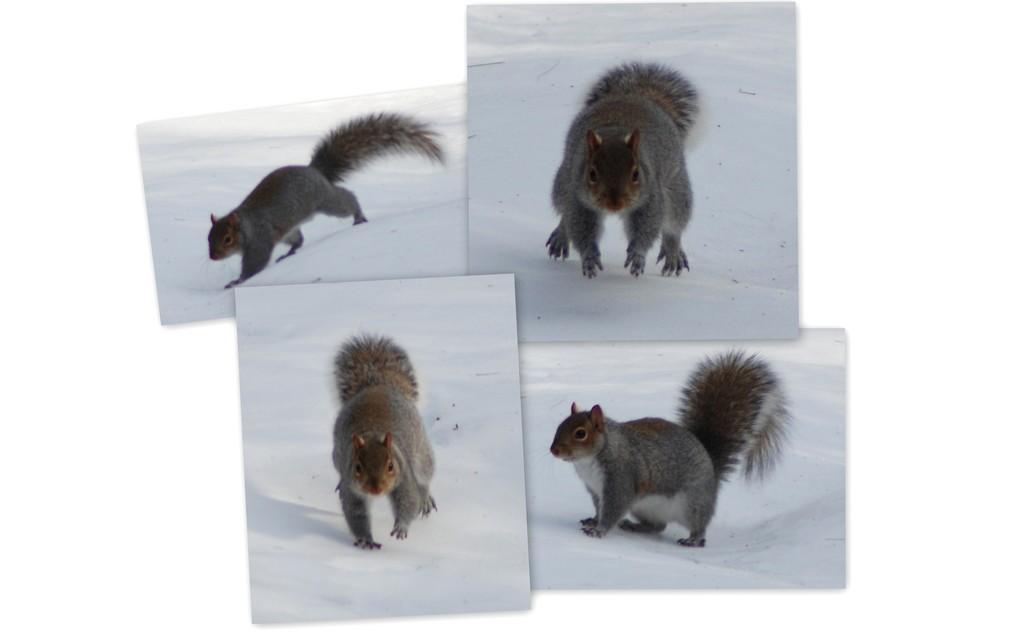Can you describe this image briefly? In the picture I can see the collage images of a squirrel in the snow. 